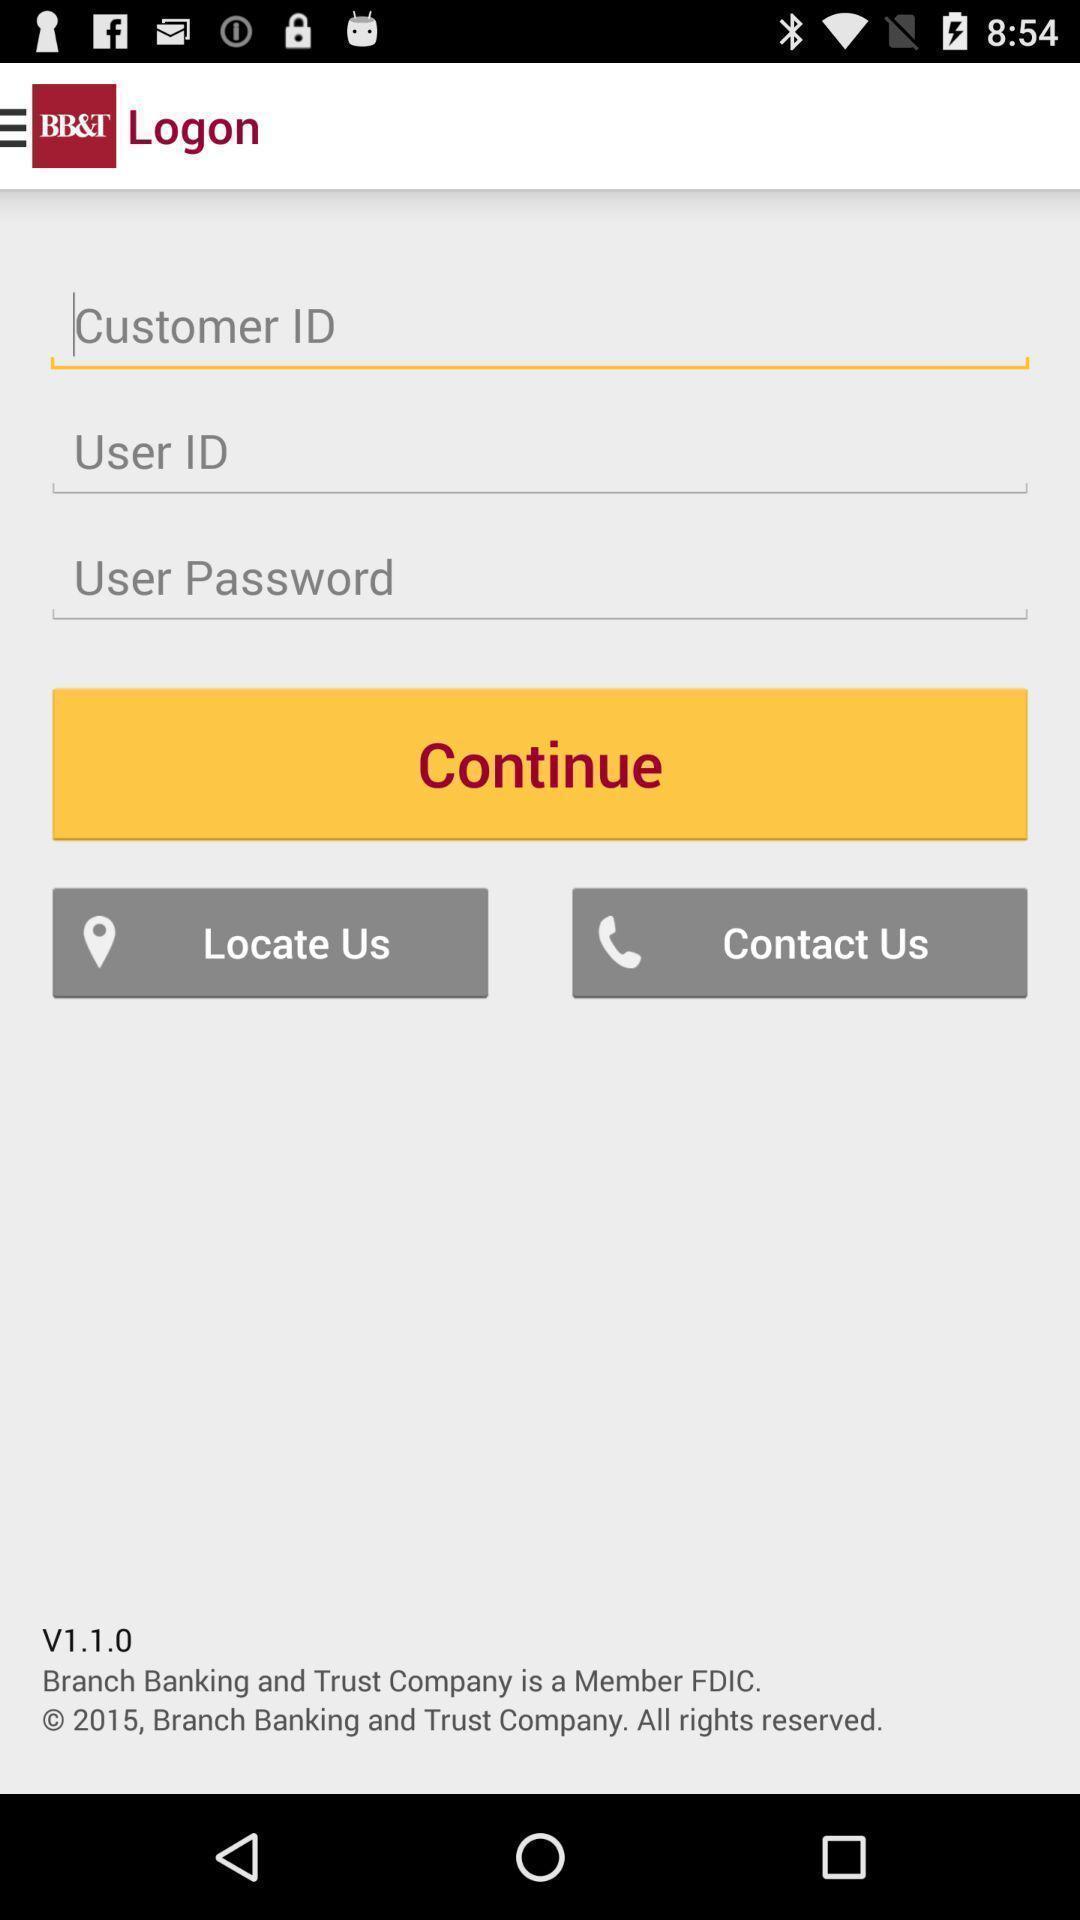Explain what's happening in this screen capture. Welcome to the sign in page. 